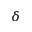Convert formula to latex. <formula><loc_0><loc_0><loc_500><loc_500>\delta</formula> 